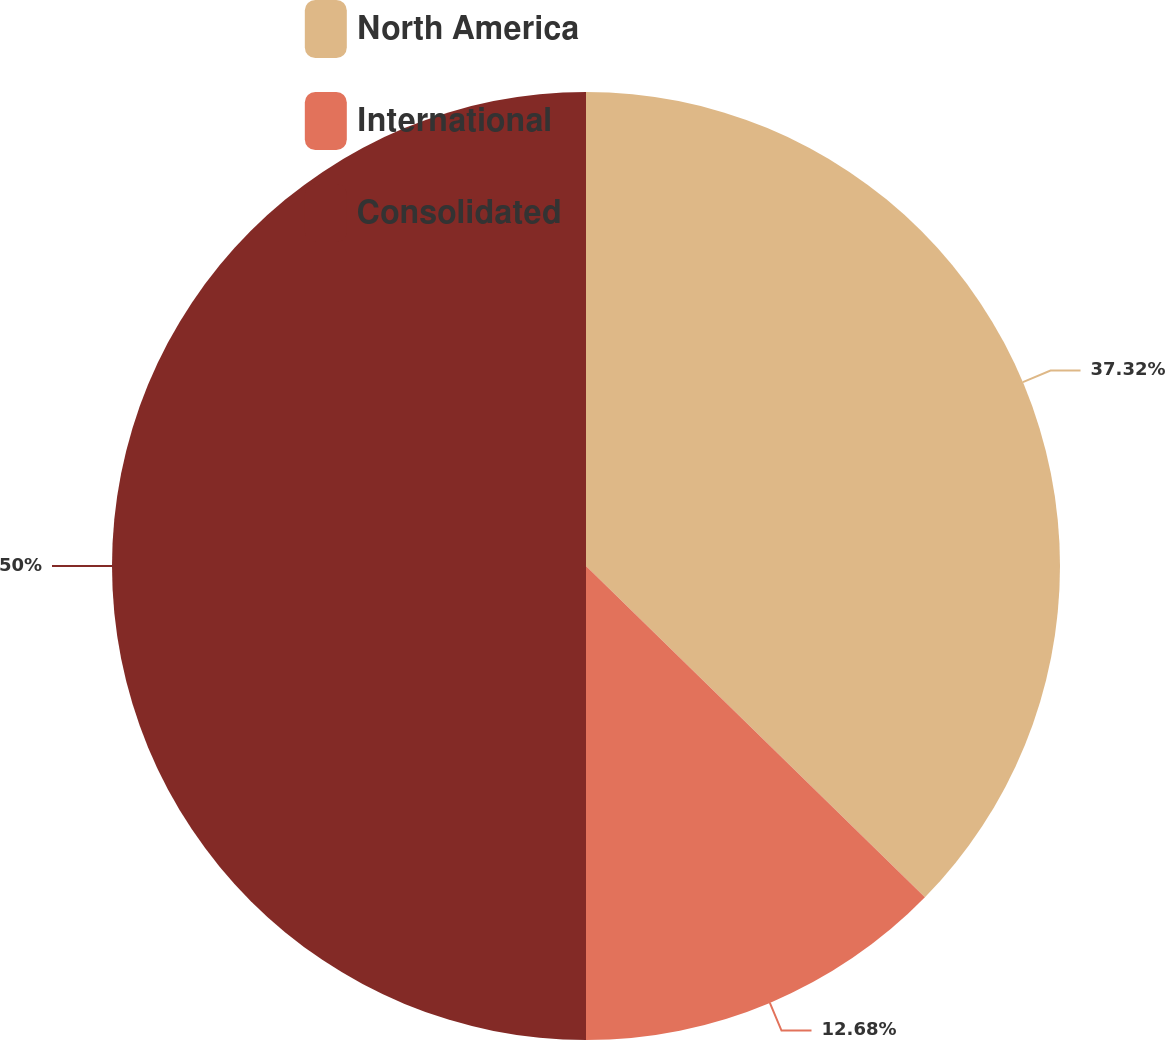Convert chart to OTSL. <chart><loc_0><loc_0><loc_500><loc_500><pie_chart><fcel>North America<fcel>International<fcel>Consolidated<nl><fcel>37.32%<fcel>12.68%<fcel>50.0%<nl></chart> 